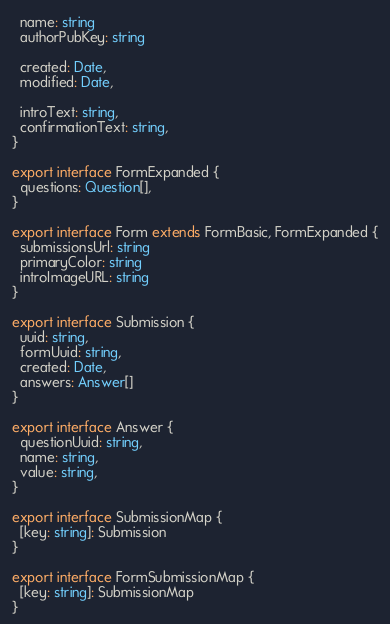<code> <loc_0><loc_0><loc_500><loc_500><_TypeScript_>  name: string
  authorPubKey: string

  created: Date,
  modified: Date,

  introText: string,
  confirmationText: string,
}

export interface FormExpanded {
  questions: Question[],
}

export interface Form extends FormBasic, FormExpanded {
  submissionsUrl: string
  primaryColor: string
  introImageURL: string
}

export interface Submission {
  uuid: string,
  formUuid: string,
  created: Date,
  answers: Answer[]
}

export interface Answer {
  questionUuid: string,
  name: string,
  value: string,
}

export interface SubmissionMap {
  [key: string]: Submission
}

export interface FormSubmissionMap {
  [key: string]: SubmissionMap
}
</code> 